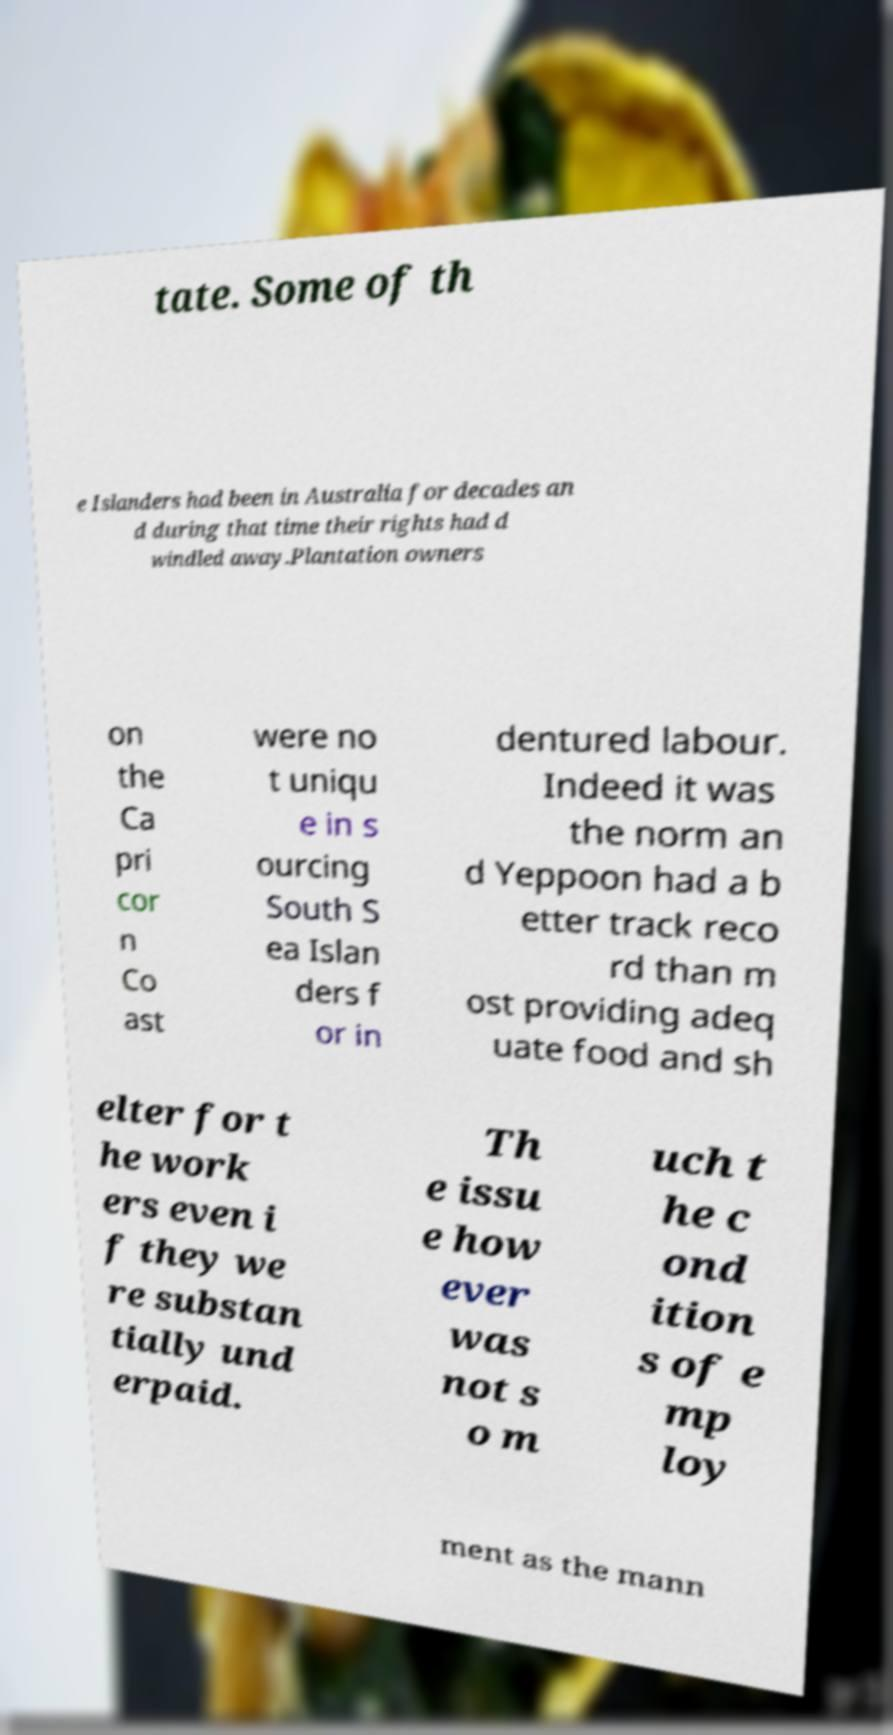Can you accurately transcribe the text from the provided image for me? tate. Some of th e Islanders had been in Australia for decades an d during that time their rights had d windled away.Plantation owners on the Ca pri cor n Co ast were no t uniqu e in s ourcing South S ea Islan ders f or in dentured labour. Indeed it was the norm an d Yeppoon had a b etter track reco rd than m ost providing adeq uate food and sh elter for t he work ers even i f they we re substan tially und erpaid. Th e issu e how ever was not s o m uch t he c ond ition s of e mp loy ment as the mann 